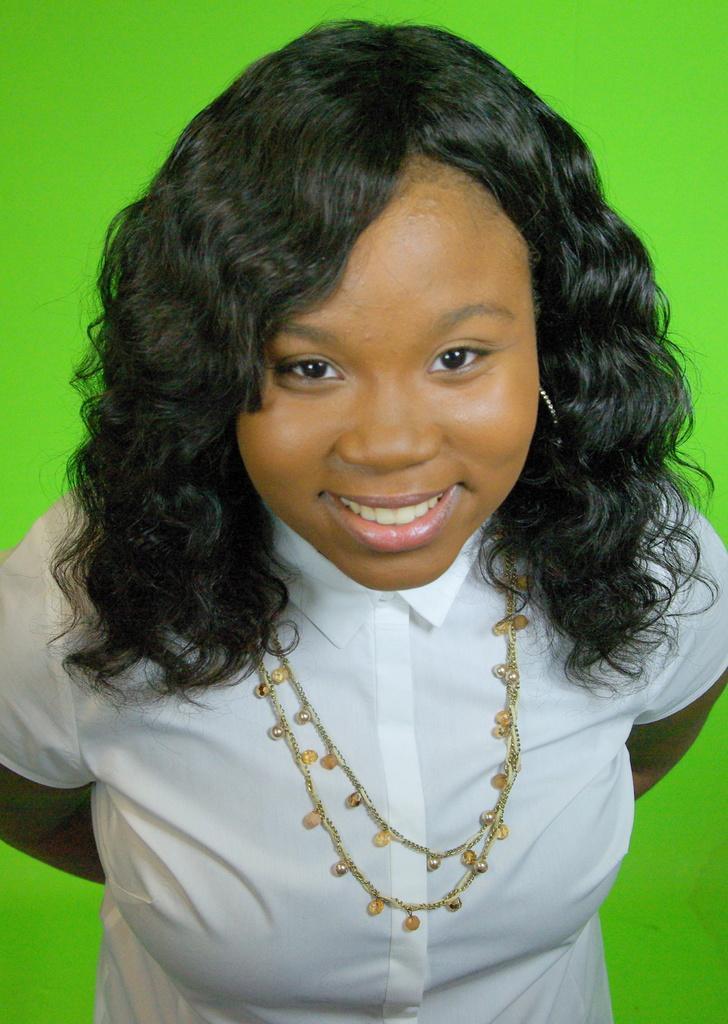Please provide a concise description of this image. In this picture I can observe a woman. She is smiling. This woman is wearing white color dress and a chain in her neck. The background is in green color. 